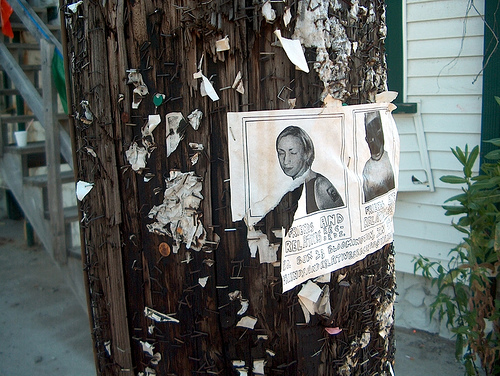<image>
Is the picture next to the stairs? Yes. The picture is positioned adjacent to the stairs, located nearby in the same general area. 